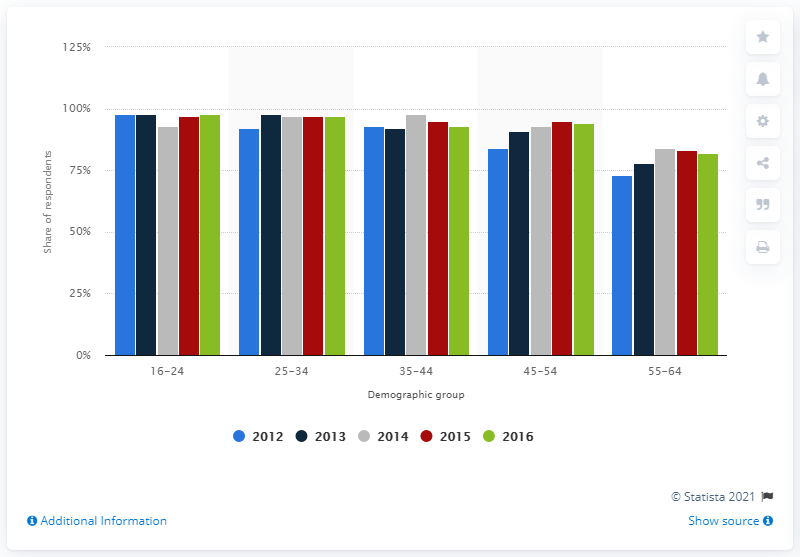Highlight a few significant elements in this photo. During the survey period, 97% of 25 to 34 year olds used the internet. In 2012, the UK conducted a survey on internet usage. 